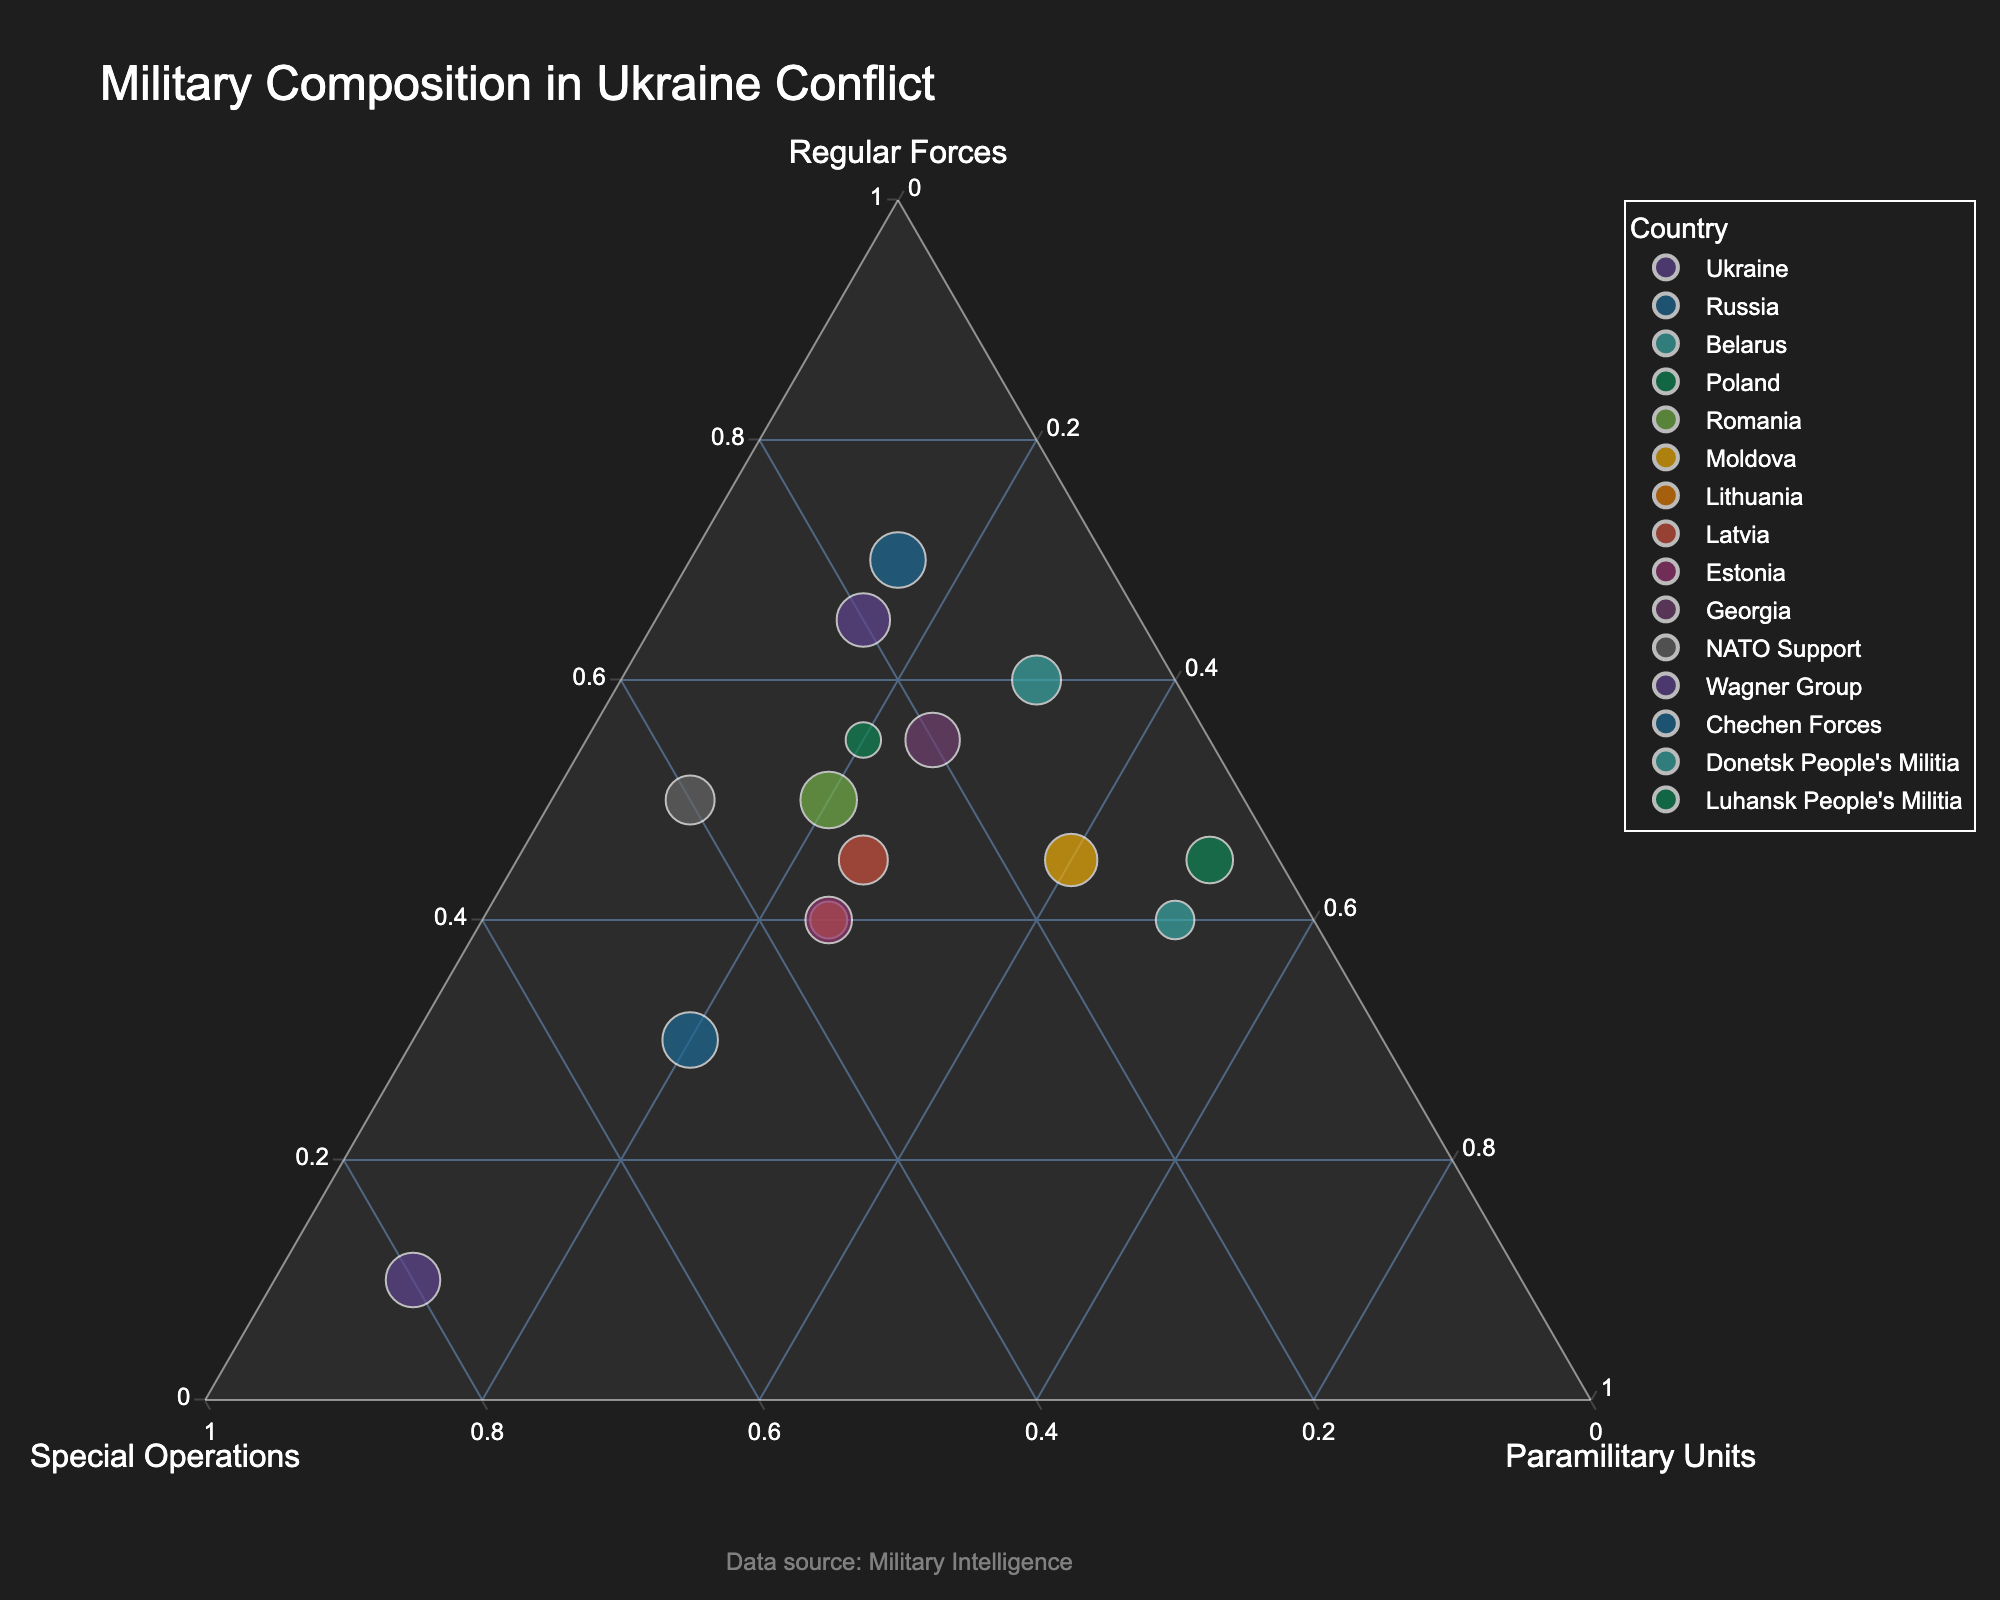What is the title of the plot? The title of the plot is displayed at the top and provides an overview of what the figure represents. Look at the top of the figure where the largest text is displayed.
Answer: Military Composition in Ukraine Conflict How many countries and groups are displayed in the figure? Count each labeled data point, which represents a country or a military group.
Answer: 15 Which country or group has the highest percentage of Special Operations forces? Observe the position within the ternary plot. The point closest to the Special Operations axis has the highest percentage of these forces.
Answer: Wagner Group Compare the Regular Forces percentage between Ukraine and Poland. Which country has a higher percentage? Look at the positions of Ukraine and Poland on the Regular Forces axis. The country represented by the point closer to the Regular Forces vertex has a higher percentage.
Answer: Ukraine What’s the sum of the Special Operations and Paramilitary Units percentages for NATO Support? Add the percentages of Special Operations (40%) and Paramilitary Units (10%) for NATO Support. 40 + 10 = 50.
Answer: 50 Which country has the smallest percentage of Regular Forces? Find the point closest to the edge opposite the Regular Forces vertex.
Answer: Wagner Group Compare the Paramilitary Units proportion of Belarus and Moldova. Which country has a higher percentage? Look along the Paramilitary Units axis and find the points for Belarus and Moldova. The point closer to the Paramilitary Units vertex has a higher percentage.
Answer: Moldova Which country or group has an equal distribution of Regular Forces and Paramilitary Units? Look for a point that lies along the axis where Regular Forces and Paramilitary Units are equal.
Answer: Donetsk People's Militia What's the percentage difference in Special Operations forces between Lithuania and Estonia? Subtract the Special Operations percentage of Estonia (35%) from Lithuania (35%). 35 - 35 = 0.
Answer: 0 In which section of the ternary plot do the Chechen Forces position themselves predominantly? Find the Chechen Forces on the plot and see which vertex they are closest to represent the dominant force type.
Answer: Special Operations 